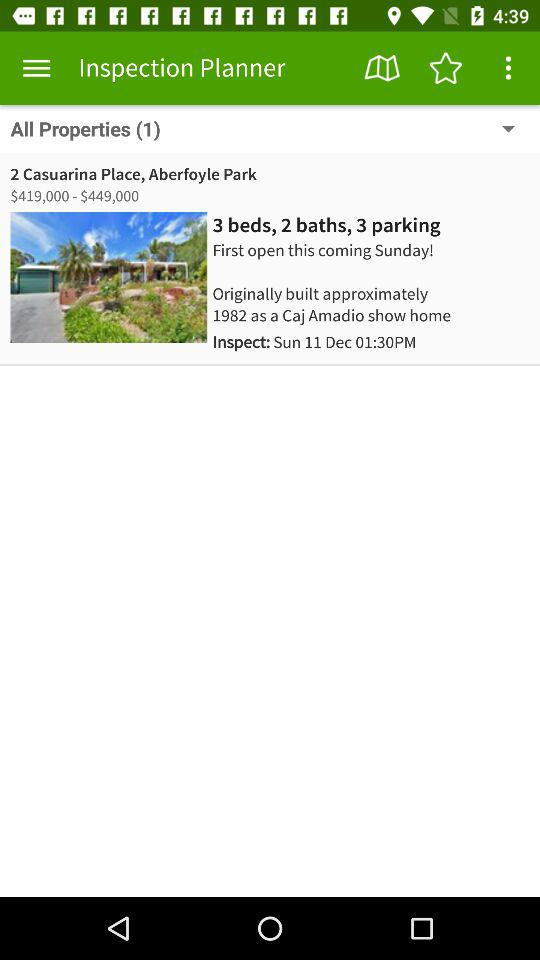How many more beds are there than baths?
Answer the question using a single word or phrase. 1 